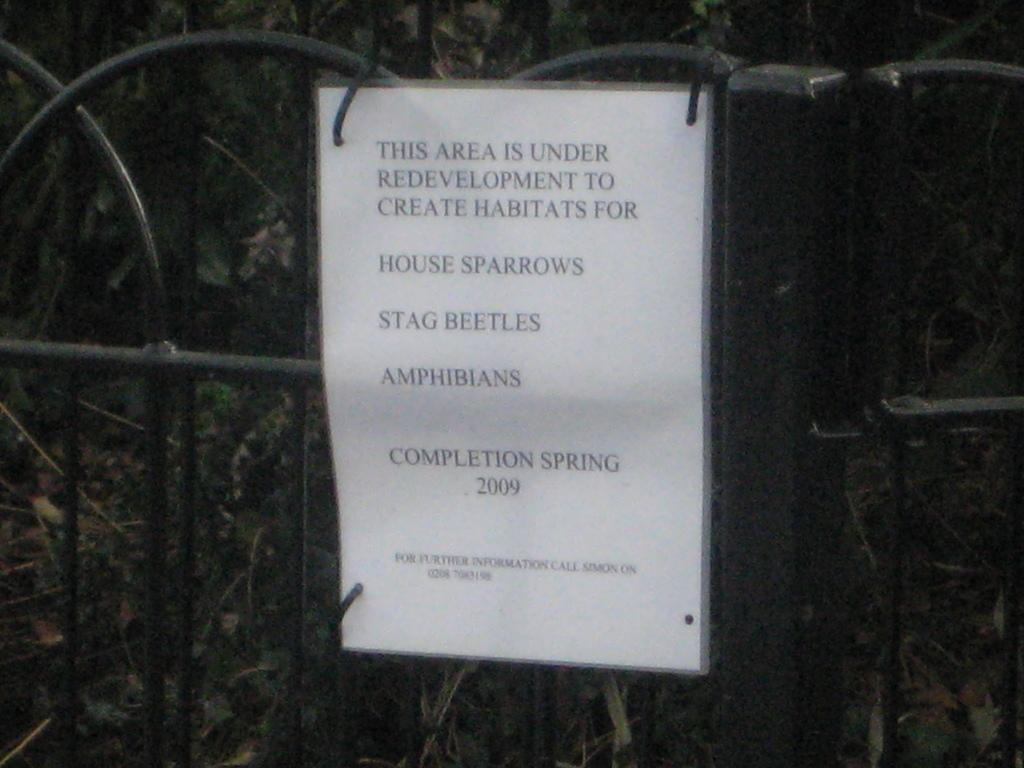What type of objects are made of metal in the image? There are metal rods in the image. What is the paper in the image used for? The paper contains text. What can be seen in the background of the image? There are plants in the background of the image. Can you see the nose of the owl in the image? There is no owl present in the image, so it is not possible to see its nose. 